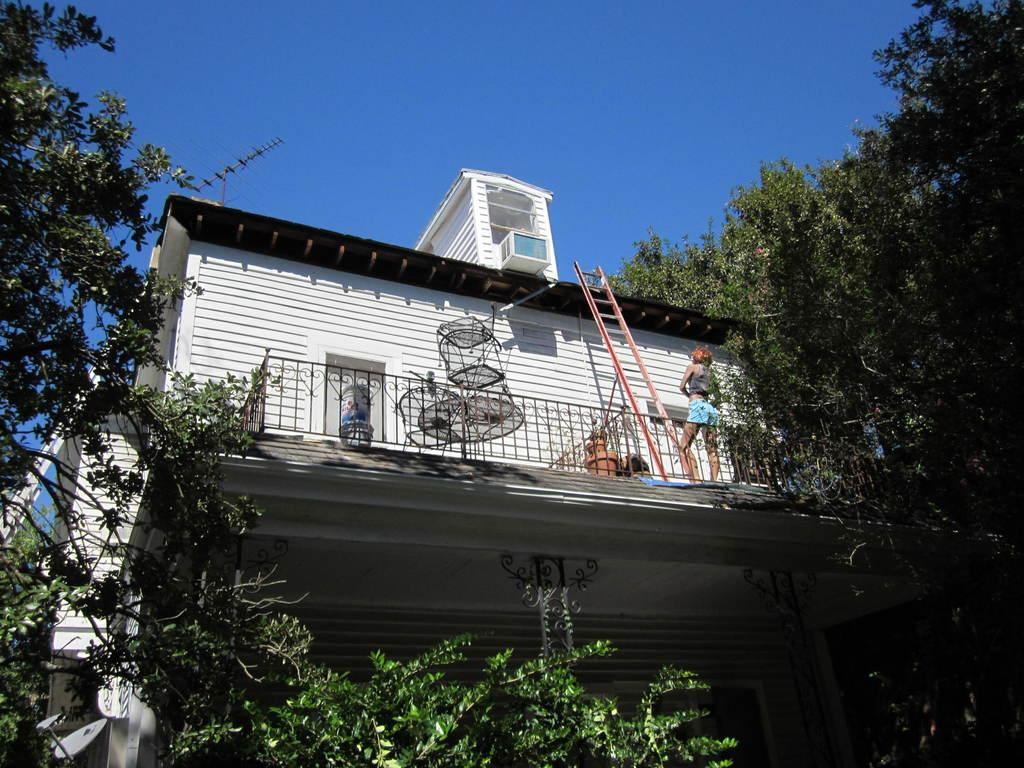What type of structure is present in the image? There is a building in the image. Can you describe the person in the image? There is a person in the image. What object is present that can be used for climbing? There is a ladder in the image. What type of natural vegetation can be seen around the image? There are trees visible around the image. Is there a ghost visible in the image? No, there is no ghost present in the image. Can you describe the yak that is standing next to the person in the image? There is no yak present in the image; only a person, a building, a ladder, and trees are visible. 